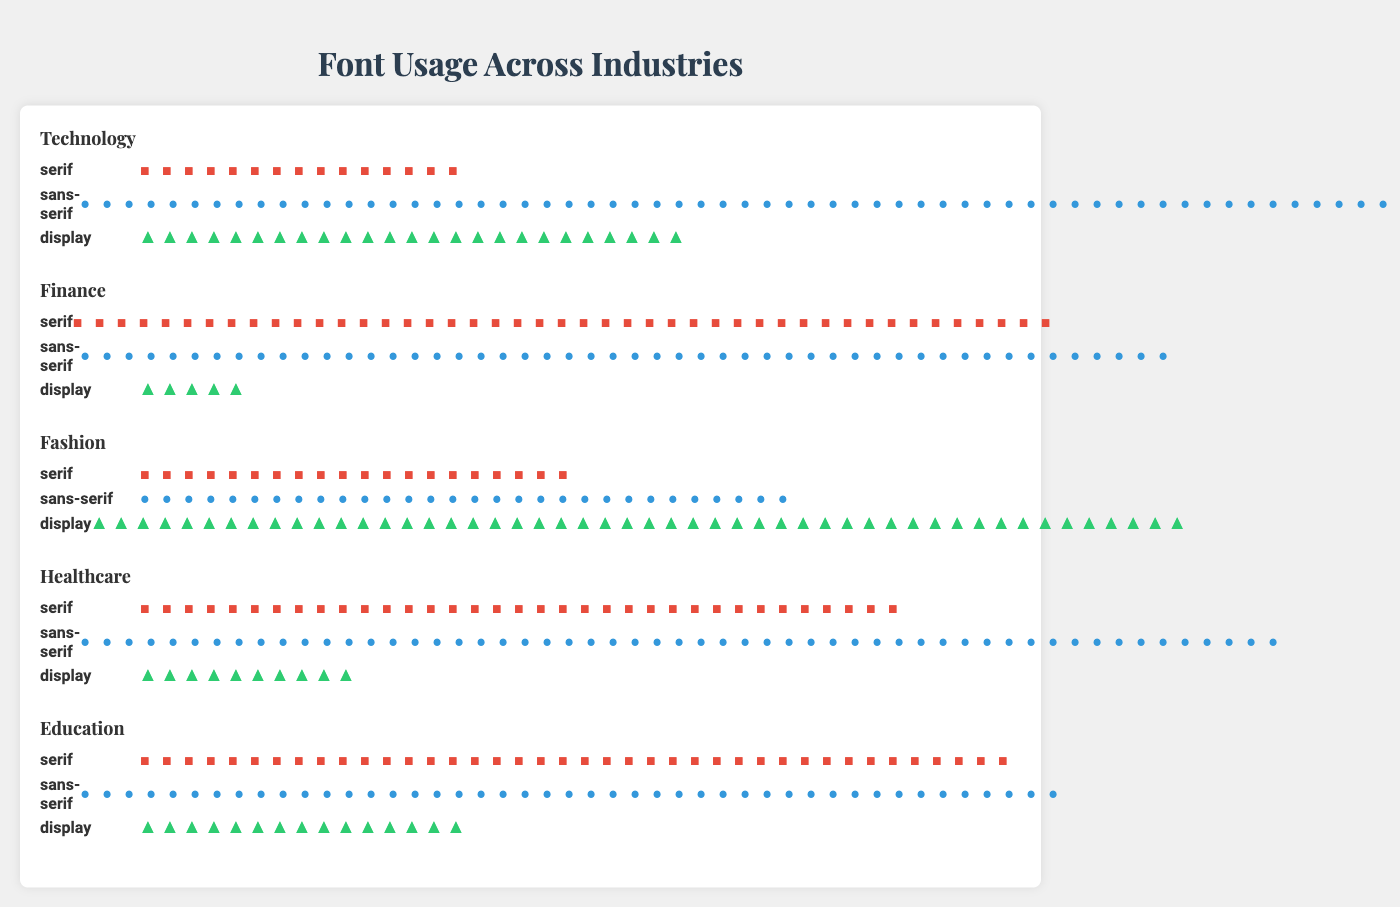Which industry uses serif fonts the most? Look at the industry names and their serif icon counts. Education has the highest count with 40 serif fonts.
Answer: Education How many more sans-serif fonts are used in Technology compared to Fashion? Subtract the number of sans-serif fonts in Fashion (30) from those in Technology (60). 60 - 30 = 30
Answer: 30 What is the total number of display fonts used across all industries? Add the display fonts from all industries: Technology (25), Finance (5), Fashion (50), Healthcare (10), Education (15). 25 + 5 + 50 + 10 + 15 = 105
Answer: 105 Which industry has the least number of serif fonts, and how many are there? Identify the industries and their serif font counts. Technology has the least with 15 serif fonts.
Answer: Technology, 15 What is the sum of serif and sans-serif fonts used in Healthcare? Add the number of serif (35) and sans-serif (55) fonts in Healthcare: 35 + 55 = 90
Answer: 90 Compare the usage of display fonts between Finance and Fashion. By how much does one exceed the other? Subtract the display fonts in Finance (5) from those in Fashion (50). 50 - 5 = 45
Answer: 45 In which industry is the ratio of sans-serif to display fonts exactly 1:1? Identify the industry where the counts of sans-serif and display fonts are equal. No industry fits this ratio.
Answer: None How does the number of sans-serif fonts in Education compare to the number of sans-serif fonts in Finance? Look at the counts of sans-serif fonts in Education (45) and Finance (50). Finance has 5 more than Education.
Answer: Finance has 5 more What's the percentage of serif fonts used in the Fashion industry relative to its total font usage? Calculate the total fonts in Fashion (20 serif + 30 sans-serif + 50 display = 100) and find the percentage: (20/100) * 100% = 20%
Answer: 20% Identify the industry with the most balanced distribution of serif, sans-serif, and display fonts. Assess the font counts in each industry. Education (40 serif, 45 sans-serif, 15 display) appears the most balanced.
Answer: Education 